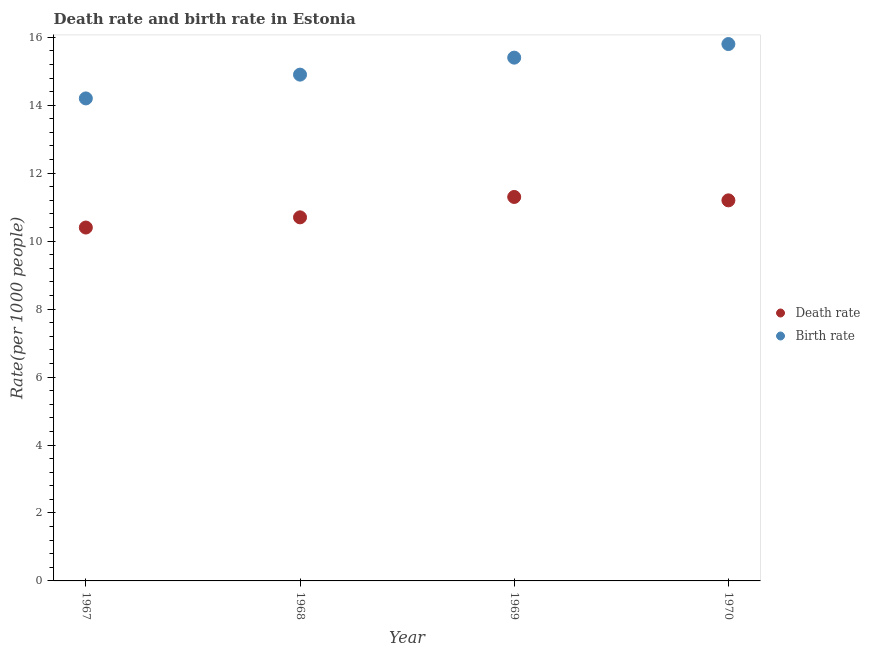Across all years, what is the maximum death rate?
Give a very brief answer. 11.3. In which year was the death rate maximum?
Provide a short and direct response. 1969. In which year was the birth rate minimum?
Your answer should be compact. 1967. What is the total birth rate in the graph?
Your answer should be very brief. 60.3. What is the difference between the birth rate in 1969 and the death rate in 1970?
Your answer should be compact. 4.2. What is the average birth rate per year?
Your response must be concise. 15.07. In the year 1970, what is the difference between the death rate and birth rate?
Offer a very short reply. -4.6. In how many years, is the death rate greater than 5.6?
Your answer should be compact. 4. What is the ratio of the birth rate in 1967 to that in 1970?
Provide a succinct answer. 0.9. Is the birth rate in 1969 less than that in 1970?
Your answer should be compact. Yes. What is the difference between the highest and the second highest birth rate?
Give a very brief answer. 0.4. What is the difference between the highest and the lowest birth rate?
Your answer should be very brief. 1.6. Is the sum of the birth rate in 1968 and 1969 greater than the maximum death rate across all years?
Give a very brief answer. Yes. Is the death rate strictly greater than the birth rate over the years?
Provide a short and direct response. No. How many years are there in the graph?
Provide a short and direct response. 4. Are the values on the major ticks of Y-axis written in scientific E-notation?
Make the answer very short. No. Does the graph contain any zero values?
Your response must be concise. No. How many legend labels are there?
Give a very brief answer. 2. How are the legend labels stacked?
Offer a very short reply. Vertical. What is the title of the graph?
Ensure brevity in your answer.  Death rate and birth rate in Estonia. What is the label or title of the X-axis?
Offer a terse response. Year. What is the label or title of the Y-axis?
Provide a short and direct response. Rate(per 1000 people). What is the Rate(per 1000 people) in Death rate in 1967?
Offer a very short reply. 10.4. What is the Rate(per 1000 people) in Birth rate in 1968?
Ensure brevity in your answer.  14.9. What is the Rate(per 1000 people) in Birth rate in 1969?
Offer a very short reply. 15.4. What is the Rate(per 1000 people) of Death rate in 1970?
Provide a short and direct response. 11.2. Across all years, what is the maximum Rate(per 1000 people) of Death rate?
Your answer should be compact. 11.3. Across all years, what is the minimum Rate(per 1000 people) of Death rate?
Provide a short and direct response. 10.4. Across all years, what is the minimum Rate(per 1000 people) of Birth rate?
Provide a succinct answer. 14.2. What is the total Rate(per 1000 people) of Death rate in the graph?
Your answer should be compact. 43.6. What is the total Rate(per 1000 people) of Birth rate in the graph?
Offer a terse response. 60.3. What is the difference between the Rate(per 1000 people) of Death rate in 1967 and that in 1968?
Offer a terse response. -0.3. What is the difference between the Rate(per 1000 people) of Death rate in 1967 and that in 1969?
Give a very brief answer. -0.9. What is the difference between the Rate(per 1000 people) of Death rate in 1967 and that in 1970?
Make the answer very short. -0.8. What is the difference between the Rate(per 1000 people) in Death rate in 1968 and that in 1969?
Provide a succinct answer. -0.6. What is the difference between the Rate(per 1000 people) in Birth rate in 1968 and that in 1970?
Make the answer very short. -0.9. What is the difference between the Rate(per 1000 people) in Death rate in 1969 and that in 1970?
Offer a very short reply. 0.1. What is the difference between the Rate(per 1000 people) in Birth rate in 1969 and that in 1970?
Provide a short and direct response. -0.4. What is the difference between the Rate(per 1000 people) in Death rate in 1967 and the Rate(per 1000 people) in Birth rate in 1968?
Give a very brief answer. -4.5. What is the difference between the Rate(per 1000 people) in Death rate in 1967 and the Rate(per 1000 people) in Birth rate in 1969?
Offer a very short reply. -5. What is the difference between the Rate(per 1000 people) in Death rate in 1968 and the Rate(per 1000 people) in Birth rate in 1969?
Give a very brief answer. -4.7. What is the average Rate(per 1000 people) in Birth rate per year?
Make the answer very short. 15.07. In the year 1967, what is the difference between the Rate(per 1000 people) of Death rate and Rate(per 1000 people) of Birth rate?
Provide a short and direct response. -3.8. In the year 1969, what is the difference between the Rate(per 1000 people) in Death rate and Rate(per 1000 people) in Birth rate?
Offer a terse response. -4.1. What is the ratio of the Rate(per 1000 people) in Birth rate in 1967 to that in 1968?
Your response must be concise. 0.95. What is the ratio of the Rate(per 1000 people) in Death rate in 1967 to that in 1969?
Give a very brief answer. 0.92. What is the ratio of the Rate(per 1000 people) in Birth rate in 1967 to that in 1969?
Provide a succinct answer. 0.92. What is the ratio of the Rate(per 1000 people) in Death rate in 1967 to that in 1970?
Your response must be concise. 0.93. What is the ratio of the Rate(per 1000 people) of Birth rate in 1967 to that in 1970?
Provide a short and direct response. 0.9. What is the ratio of the Rate(per 1000 people) in Death rate in 1968 to that in 1969?
Provide a succinct answer. 0.95. What is the ratio of the Rate(per 1000 people) in Birth rate in 1968 to that in 1969?
Give a very brief answer. 0.97. What is the ratio of the Rate(per 1000 people) in Death rate in 1968 to that in 1970?
Your response must be concise. 0.96. What is the ratio of the Rate(per 1000 people) of Birth rate in 1968 to that in 1970?
Provide a succinct answer. 0.94. What is the ratio of the Rate(per 1000 people) of Death rate in 1969 to that in 1970?
Your answer should be very brief. 1.01. What is the ratio of the Rate(per 1000 people) in Birth rate in 1969 to that in 1970?
Provide a succinct answer. 0.97. What is the difference between the highest and the second highest Rate(per 1000 people) of Death rate?
Give a very brief answer. 0.1. What is the difference between the highest and the second highest Rate(per 1000 people) in Birth rate?
Your answer should be very brief. 0.4. What is the difference between the highest and the lowest Rate(per 1000 people) of Death rate?
Provide a succinct answer. 0.9. 